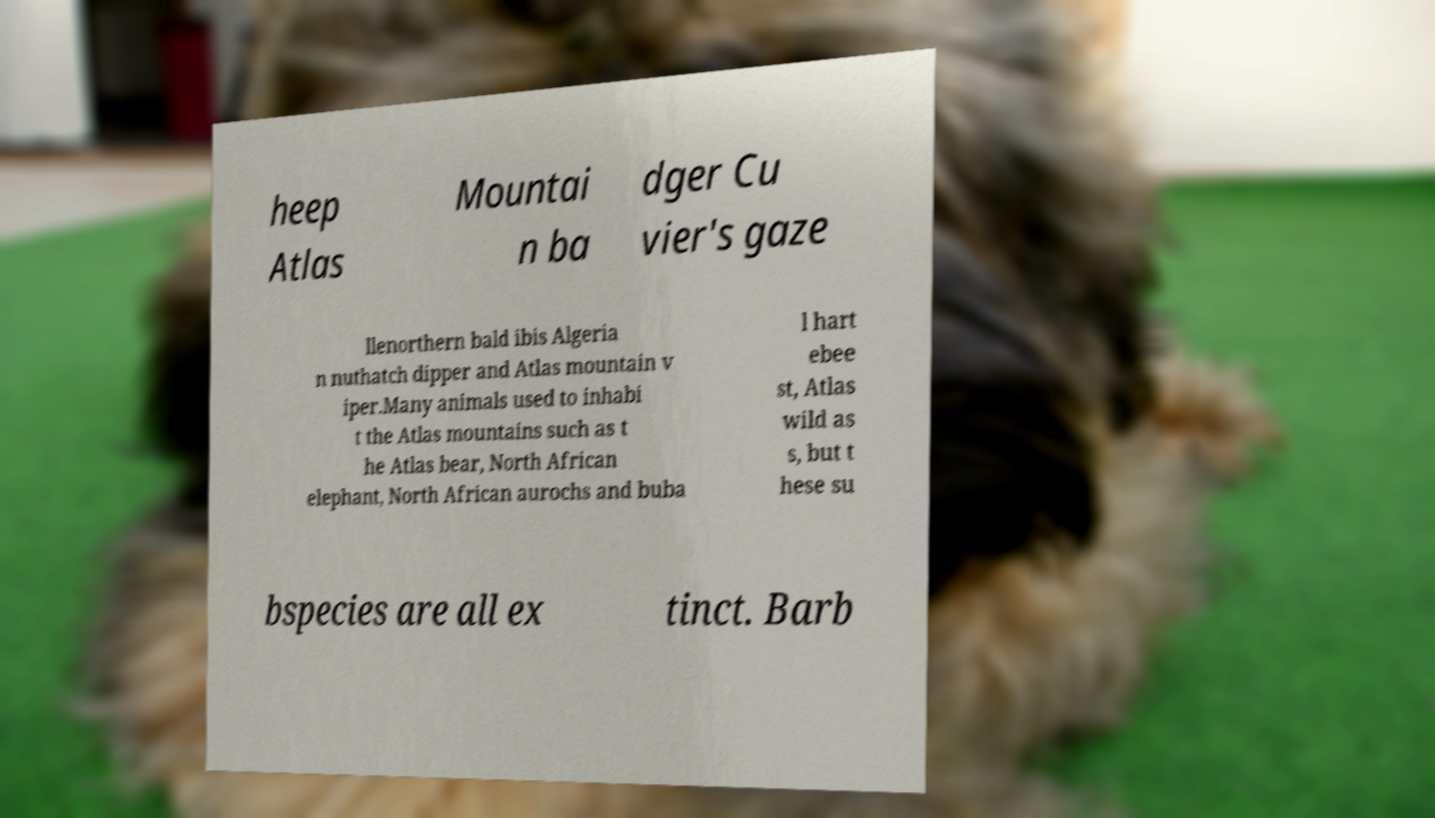Please identify and transcribe the text found in this image. heep Atlas Mountai n ba dger Cu vier's gaze llenorthern bald ibis Algeria n nuthatch dipper and Atlas mountain v iper.Many animals used to inhabi t the Atlas mountains such as t he Atlas bear, North African elephant, North African aurochs and buba l hart ebee st, Atlas wild as s, but t hese su bspecies are all ex tinct. Barb 